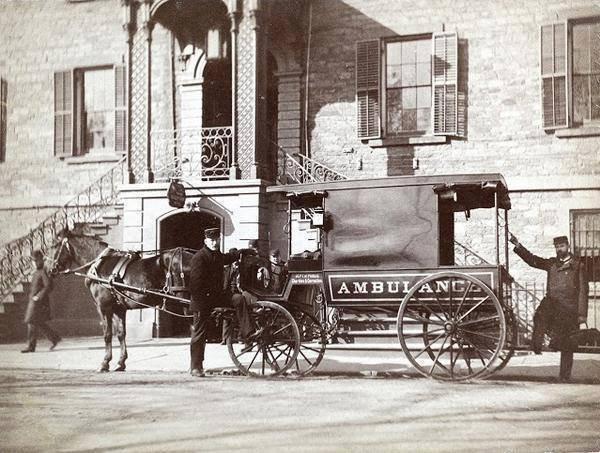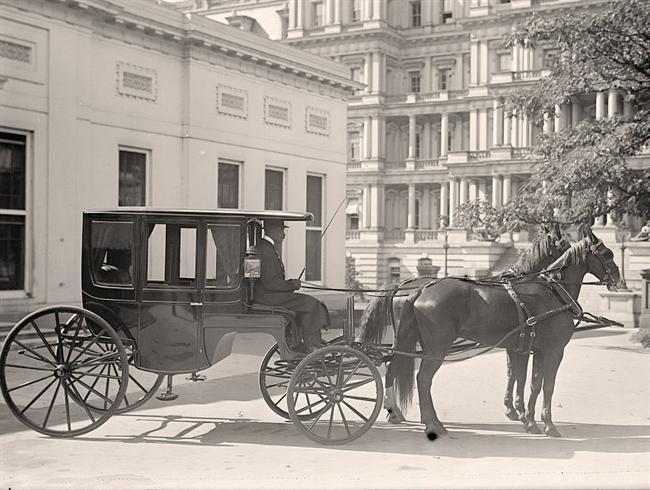The first image is the image on the left, the second image is the image on the right. Examine the images to the left and right. Is the description "One image is of a horse-drawn cart with two wheels, while the other image is a larger horse-drawn wagon with four wheels." accurate? Answer yes or no. No. The first image is the image on the left, the second image is the image on the right. Given the left and right images, does the statement "An image shows a left-facing horse-drawn cart with only two wheels." hold true? Answer yes or no. No. 